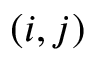<formula> <loc_0><loc_0><loc_500><loc_500>( i , j )</formula> 